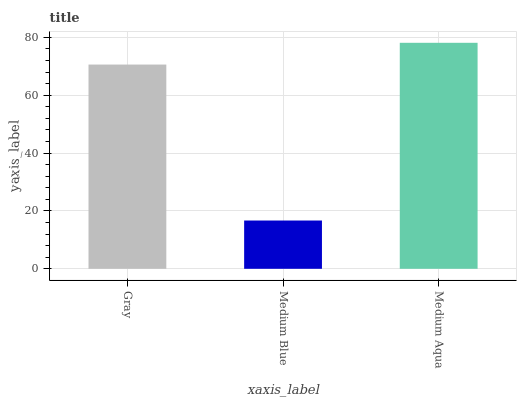Is Medium Blue the minimum?
Answer yes or no. Yes. Is Medium Aqua the maximum?
Answer yes or no. Yes. Is Medium Aqua the minimum?
Answer yes or no. No. Is Medium Blue the maximum?
Answer yes or no. No. Is Medium Aqua greater than Medium Blue?
Answer yes or no. Yes. Is Medium Blue less than Medium Aqua?
Answer yes or no. Yes. Is Medium Blue greater than Medium Aqua?
Answer yes or no. No. Is Medium Aqua less than Medium Blue?
Answer yes or no. No. Is Gray the high median?
Answer yes or no. Yes. Is Gray the low median?
Answer yes or no. Yes. Is Medium Aqua the high median?
Answer yes or no. No. Is Medium Aqua the low median?
Answer yes or no. No. 